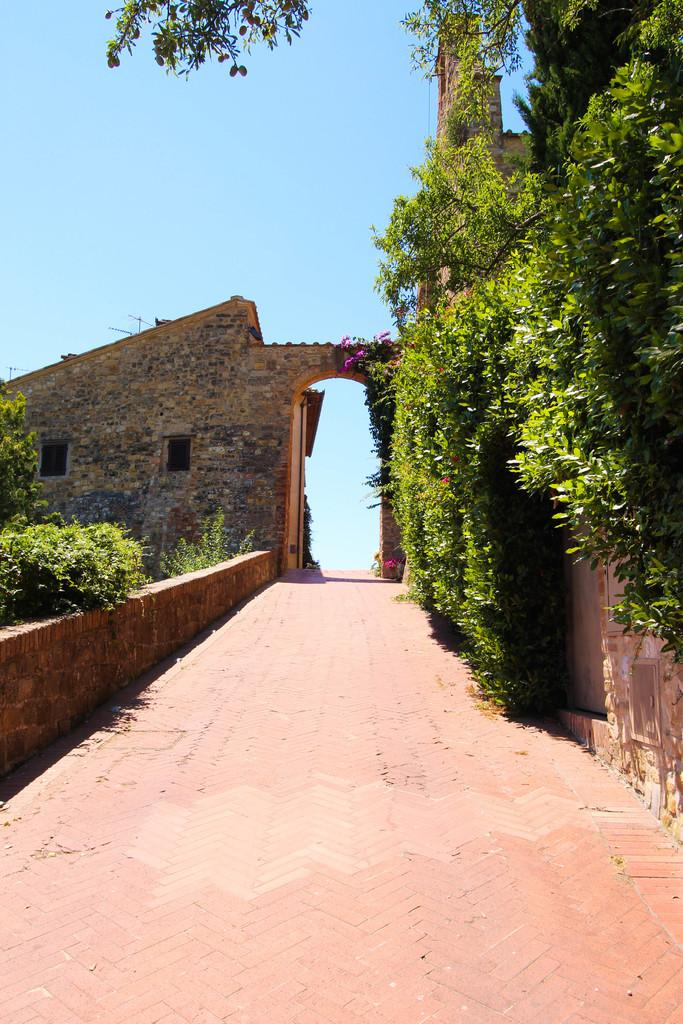What type of vegetation is on the right side of the image? There are plants on the right side of the image. What is located on the left side of the image? There is a wall on the left side of the image. Are there any plants on the left side of the image? Yes, there are plants on the left side of the image. What can be seen in the background of the image? There is a wall and flowers in the background of the image. How many pizzas are being served in the image? There are no pizzas present in the image. What type of root can be seen growing in the image? There is no root visible in the image; it features plants and walls. 